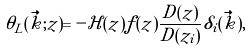Convert formula to latex. <formula><loc_0><loc_0><loc_500><loc_500>\theta _ { L } ( \vec { k } ; z ) = - \mathcal { H } ( z ) f ( z ) \frac { D ( z ) } { D ( z _ { i } ) } \delta _ { i } ( \vec { k } ) ,</formula> 